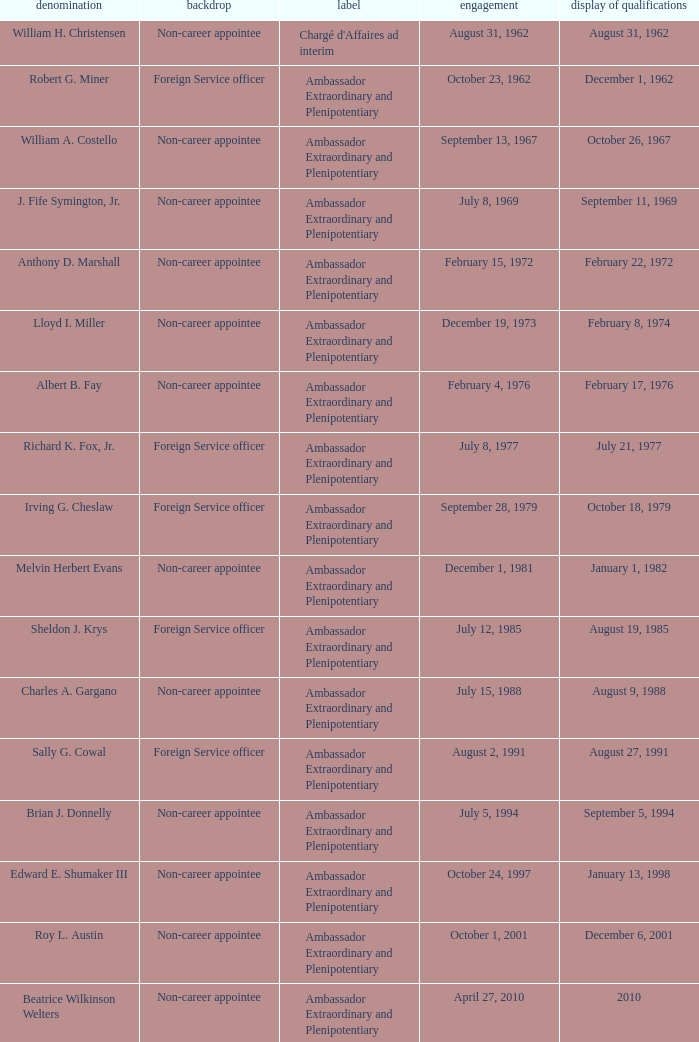Who presented their credentials at an unknown date? Margaret B. Diop. 